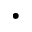Convert formula to latex. <formula><loc_0><loc_0><loc_500><loc_500>\cdot</formula> 